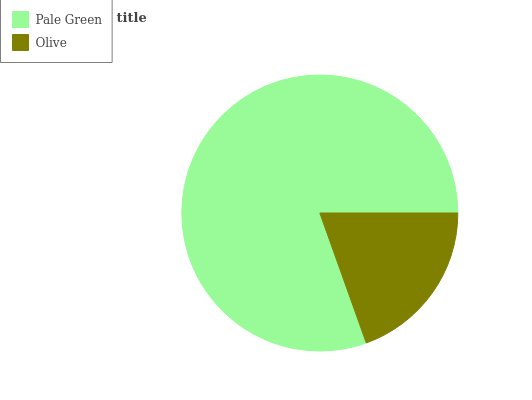Is Olive the minimum?
Answer yes or no. Yes. Is Pale Green the maximum?
Answer yes or no. Yes. Is Olive the maximum?
Answer yes or no. No. Is Pale Green greater than Olive?
Answer yes or no. Yes. Is Olive less than Pale Green?
Answer yes or no. Yes. Is Olive greater than Pale Green?
Answer yes or no. No. Is Pale Green less than Olive?
Answer yes or no. No. Is Pale Green the high median?
Answer yes or no. Yes. Is Olive the low median?
Answer yes or no. Yes. Is Olive the high median?
Answer yes or no. No. Is Pale Green the low median?
Answer yes or no. No. 